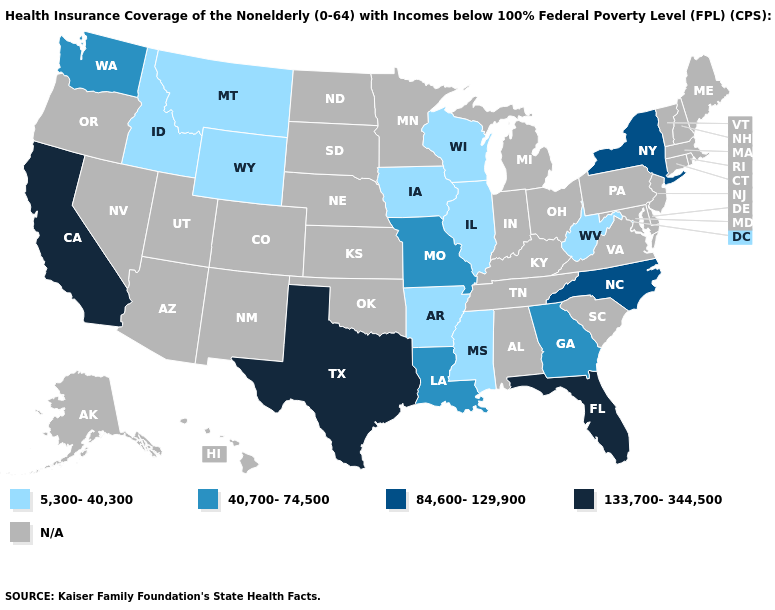What is the lowest value in the USA?
Short answer required. 5,300-40,300. What is the value of Alaska?
Keep it brief. N/A. Name the states that have a value in the range 133,700-344,500?
Be succinct. California, Florida, Texas. Which states hav the highest value in the Northeast?
Answer briefly. New York. What is the value of Alaska?
Give a very brief answer. N/A. Does West Virginia have the lowest value in the USA?
Quick response, please. Yes. What is the value of Alabama?
Be succinct. N/A. Name the states that have a value in the range 133,700-344,500?
Write a very short answer. California, Florida, Texas. Which states have the lowest value in the Northeast?
Keep it brief. New York. Which states hav the highest value in the South?
Answer briefly. Florida, Texas. What is the value of Oregon?
Concise answer only. N/A. 